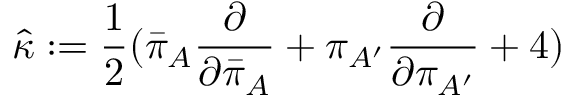<formula> <loc_0><loc_0><loc_500><loc_500>{ \hat { \kappa } } \colon = { \frac { 1 } { 2 } } { ( { \bar { \pi } } _ { A } { \frac { \partial } { \partial { \bar { \pi } } _ { A } } } + \pi _ { A ^ { \prime } } { \frac { \partial } { \partial \pi _ { A ^ { \prime } } } } + 4 ) }</formula> 